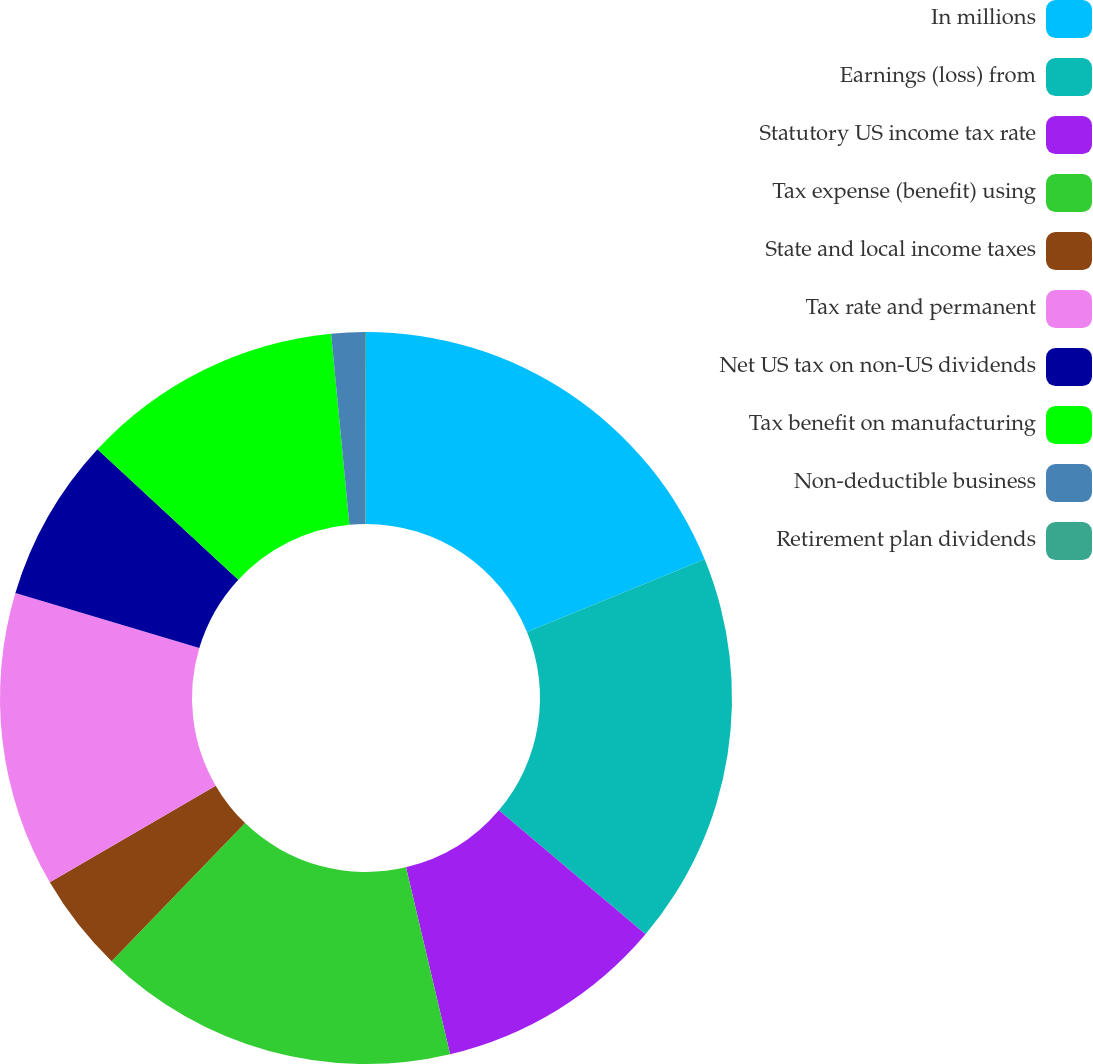<chart> <loc_0><loc_0><loc_500><loc_500><pie_chart><fcel>In millions<fcel>Earnings (loss) from<fcel>Statutory US income tax rate<fcel>Tax expense (benefit) using<fcel>State and local income taxes<fcel>Tax rate and permanent<fcel>Net US tax on non-US dividends<fcel>Tax benefit on manufacturing<fcel>Non-deductible business<fcel>Retirement plan dividends<nl><fcel>18.81%<fcel>17.36%<fcel>10.14%<fcel>15.92%<fcel>4.37%<fcel>13.03%<fcel>7.26%<fcel>11.59%<fcel>1.48%<fcel>0.04%<nl></chart> 